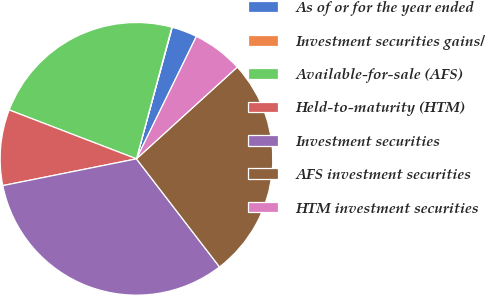Convert chart to OTSL. <chart><loc_0><loc_0><loc_500><loc_500><pie_chart><fcel>As of or for the year ended<fcel>Investment securities gains/<fcel>Available-for-sale (AFS)<fcel>Held-to-maturity (HTM)<fcel>Investment securities<fcel>AFS investment securities<fcel>HTM investment securities<nl><fcel>3.02%<fcel>0.05%<fcel>23.34%<fcel>8.98%<fcel>32.28%<fcel>26.32%<fcel>6.0%<nl></chart> 